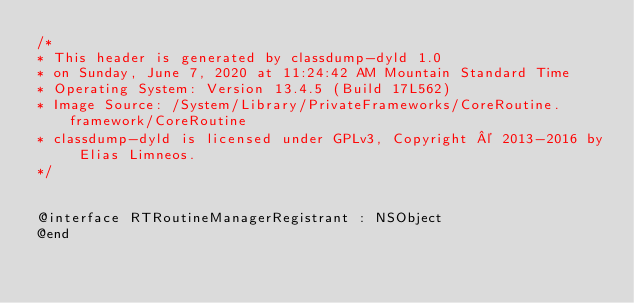<code> <loc_0><loc_0><loc_500><loc_500><_C_>/*
* This header is generated by classdump-dyld 1.0
* on Sunday, June 7, 2020 at 11:24:42 AM Mountain Standard Time
* Operating System: Version 13.4.5 (Build 17L562)
* Image Source: /System/Library/PrivateFrameworks/CoreRoutine.framework/CoreRoutine
* classdump-dyld is licensed under GPLv3, Copyright © 2013-2016 by Elias Limneos.
*/


@interface RTRoutineManagerRegistrant : NSObject
@end

</code> 